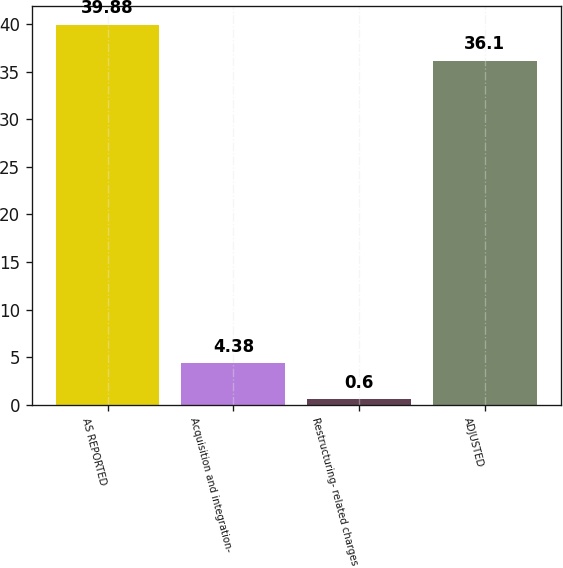Convert chart. <chart><loc_0><loc_0><loc_500><loc_500><bar_chart><fcel>AS REPORTED<fcel>Acquisition and integration-<fcel>Restructuring- related charges<fcel>ADJUSTED<nl><fcel>39.88<fcel>4.38<fcel>0.6<fcel>36.1<nl></chart> 